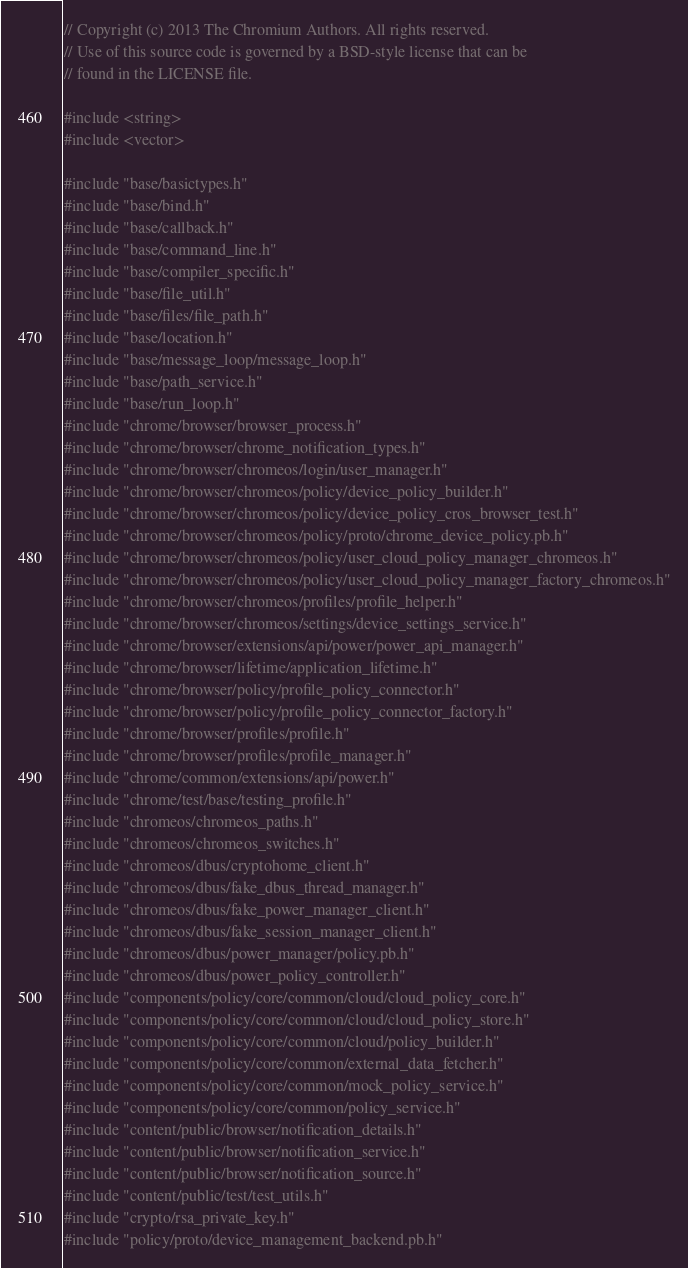Convert code to text. <code><loc_0><loc_0><loc_500><loc_500><_C++_>// Copyright (c) 2013 The Chromium Authors. All rights reserved.
// Use of this source code is governed by a BSD-style license that can be
// found in the LICENSE file.

#include <string>
#include <vector>

#include "base/basictypes.h"
#include "base/bind.h"
#include "base/callback.h"
#include "base/command_line.h"
#include "base/compiler_specific.h"
#include "base/file_util.h"
#include "base/files/file_path.h"
#include "base/location.h"
#include "base/message_loop/message_loop.h"
#include "base/path_service.h"
#include "base/run_loop.h"
#include "chrome/browser/browser_process.h"
#include "chrome/browser/chrome_notification_types.h"
#include "chrome/browser/chromeos/login/user_manager.h"
#include "chrome/browser/chromeos/policy/device_policy_builder.h"
#include "chrome/browser/chromeos/policy/device_policy_cros_browser_test.h"
#include "chrome/browser/chromeos/policy/proto/chrome_device_policy.pb.h"
#include "chrome/browser/chromeos/policy/user_cloud_policy_manager_chromeos.h"
#include "chrome/browser/chromeos/policy/user_cloud_policy_manager_factory_chromeos.h"
#include "chrome/browser/chromeos/profiles/profile_helper.h"
#include "chrome/browser/chromeos/settings/device_settings_service.h"
#include "chrome/browser/extensions/api/power/power_api_manager.h"
#include "chrome/browser/lifetime/application_lifetime.h"
#include "chrome/browser/policy/profile_policy_connector.h"
#include "chrome/browser/policy/profile_policy_connector_factory.h"
#include "chrome/browser/profiles/profile.h"
#include "chrome/browser/profiles/profile_manager.h"
#include "chrome/common/extensions/api/power.h"
#include "chrome/test/base/testing_profile.h"
#include "chromeos/chromeos_paths.h"
#include "chromeos/chromeos_switches.h"
#include "chromeos/dbus/cryptohome_client.h"
#include "chromeos/dbus/fake_dbus_thread_manager.h"
#include "chromeos/dbus/fake_power_manager_client.h"
#include "chromeos/dbus/fake_session_manager_client.h"
#include "chromeos/dbus/power_manager/policy.pb.h"
#include "chromeos/dbus/power_policy_controller.h"
#include "components/policy/core/common/cloud/cloud_policy_core.h"
#include "components/policy/core/common/cloud/cloud_policy_store.h"
#include "components/policy/core/common/cloud/policy_builder.h"
#include "components/policy/core/common/external_data_fetcher.h"
#include "components/policy/core/common/mock_policy_service.h"
#include "components/policy/core/common/policy_service.h"
#include "content/public/browser/notification_details.h"
#include "content/public/browser/notification_service.h"
#include "content/public/browser/notification_source.h"
#include "content/public/test/test_utils.h"
#include "crypto/rsa_private_key.h"
#include "policy/proto/device_management_backend.pb.h"</code> 